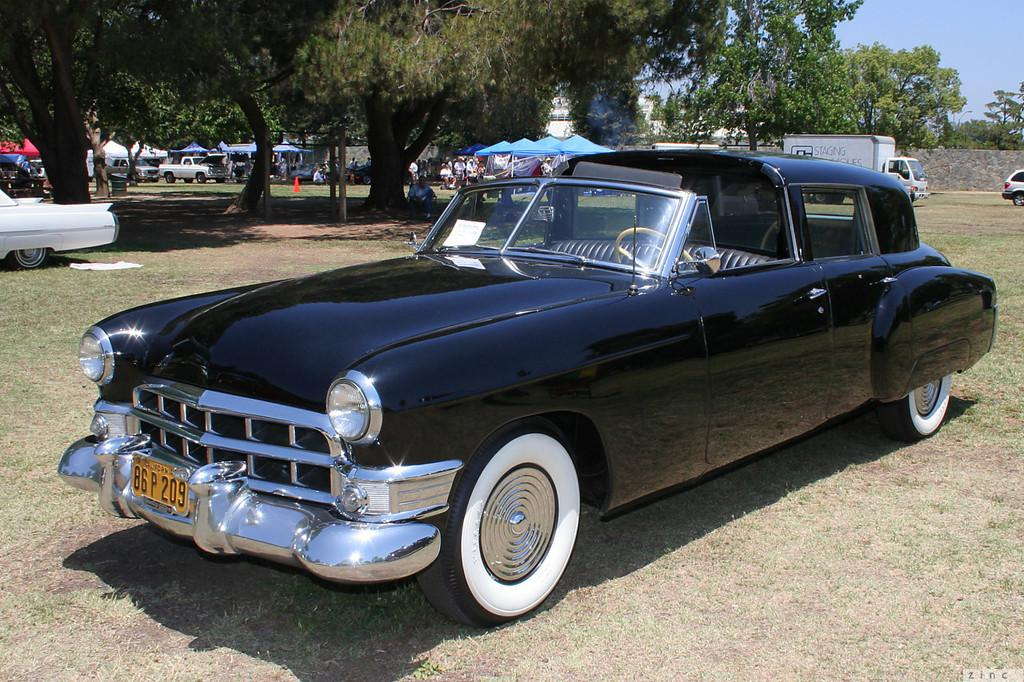What type of terrain is visible in the image? There is an open grass ground in the image. What can be seen on the grass ground? There are vehicles on the grass ground. What is visible in the background of the image? There are trees, tents, people, and the sky visible in the background of the image. How does the development of the grass ground affect the quicksand in the image? There is no quicksand present in the image, so its development is not relevant to the image. 